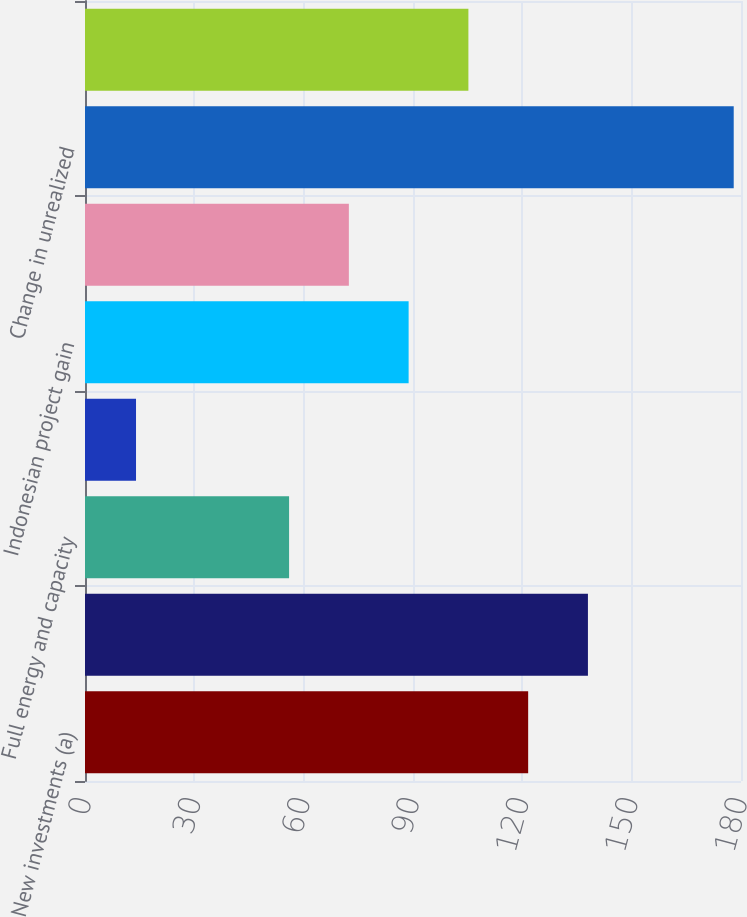<chart> <loc_0><loc_0><loc_500><loc_500><bar_chart><fcel>New investments (a)<fcel>Existing assets (a)<fcel>Full energy and capacity<fcel>Restructuring activities and<fcel>Indonesian project gain<fcel>Interest expense and other<fcel>Change in unrealized<fcel>Net income increase (decrease)<nl><fcel>121.6<fcel>138<fcel>56<fcel>14<fcel>88.8<fcel>72.4<fcel>178<fcel>105.2<nl></chart> 